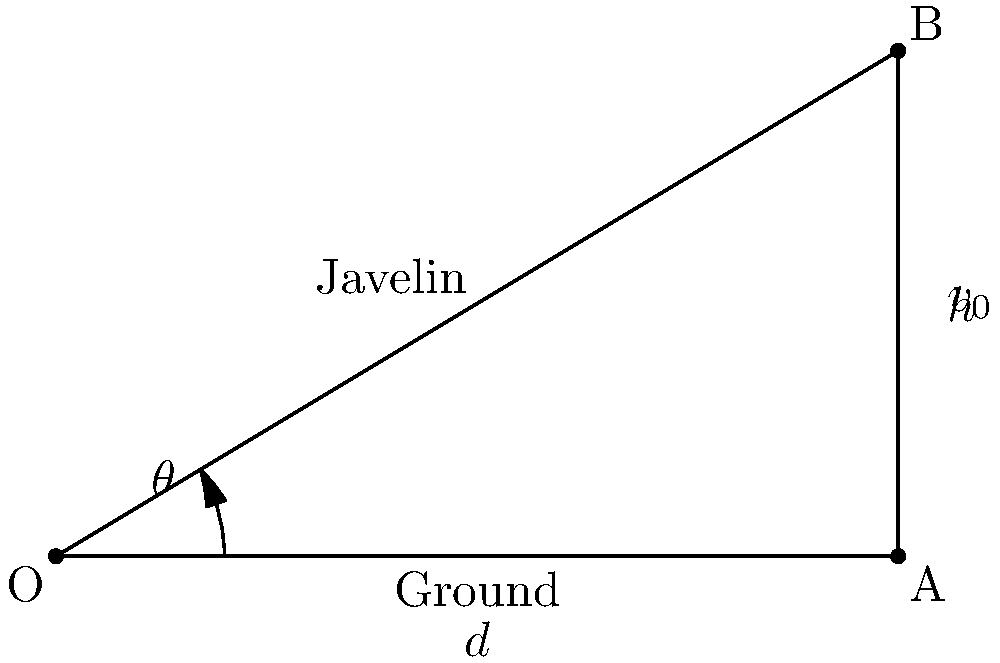In the early days of college athletics, javelin throw was introduced as a new event. As a sports historian, you're analyzing the optimal angle for a javelin throw. Given that the initial velocity of the javelin is $v_0$ and air resistance is negligible, use trigonometric functions to determine the angle $\theta$ that maximizes the horizontal distance $d$ traveled by the javelin. Express your answer in terms of $\pi$. To find the optimal angle for a javelin throw, we need to use the equations of projectile motion and trigonometry. Let's approach this step-by-step:

1) The horizontal distance $d$ traveled by the javelin is given by:
   $$d = \frac{v_0^2}{g} \sin(2\theta)$$
   where $g$ is the acceleration due to gravity.

2) To maximize $d$, we need to maximize $\sin(2\theta)$.

3) The maximum value of sine function is 1, which occurs when its argument is $\frac{\pi}{2}$ (or 90°).

4) So, we want:
   $$2\theta = \frac{\pi}{2}$$

5) Solving for $\theta$:
   $$\theta = \frac{\pi}{4}$$

6) This means the optimal angle for a javelin throw, ignoring air resistance, is 45°.

This result aligns with the historical development of javelin throwing techniques in early college athletics. Coaches and athletes would have eventually discovered through practice and rudimentary physics that a 45° angle generally produced the best results in ideal conditions.
Answer: $\frac{\pi}{4}$ 